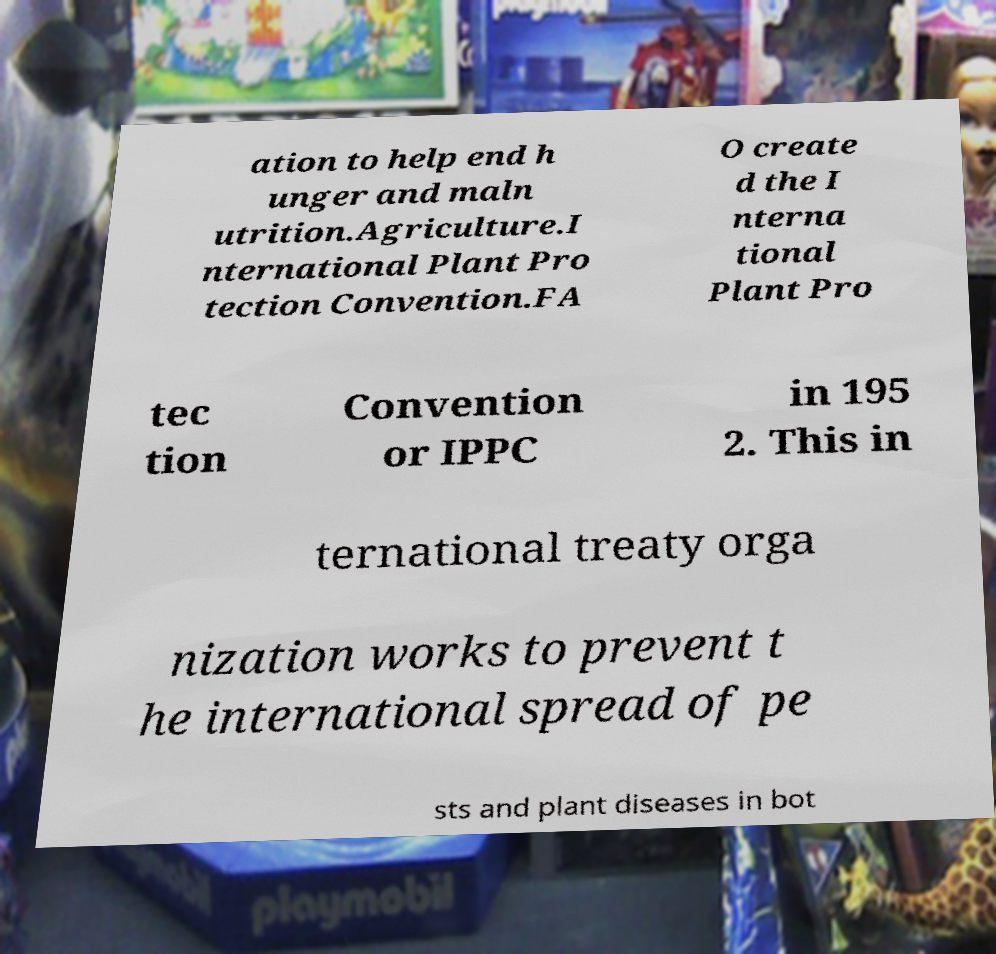For documentation purposes, I need the text within this image transcribed. Could you provide that? ation to help end h unger and maln utrition.Agriculture.I nternational Plant Pro tection Convention.FA O create d the I nterna tional Plant Pro tec tion Convention or IPPC in 195 2. This in ternational treaty orga nization works to prevent t he international spread of pe sts and plant diseases in bot 